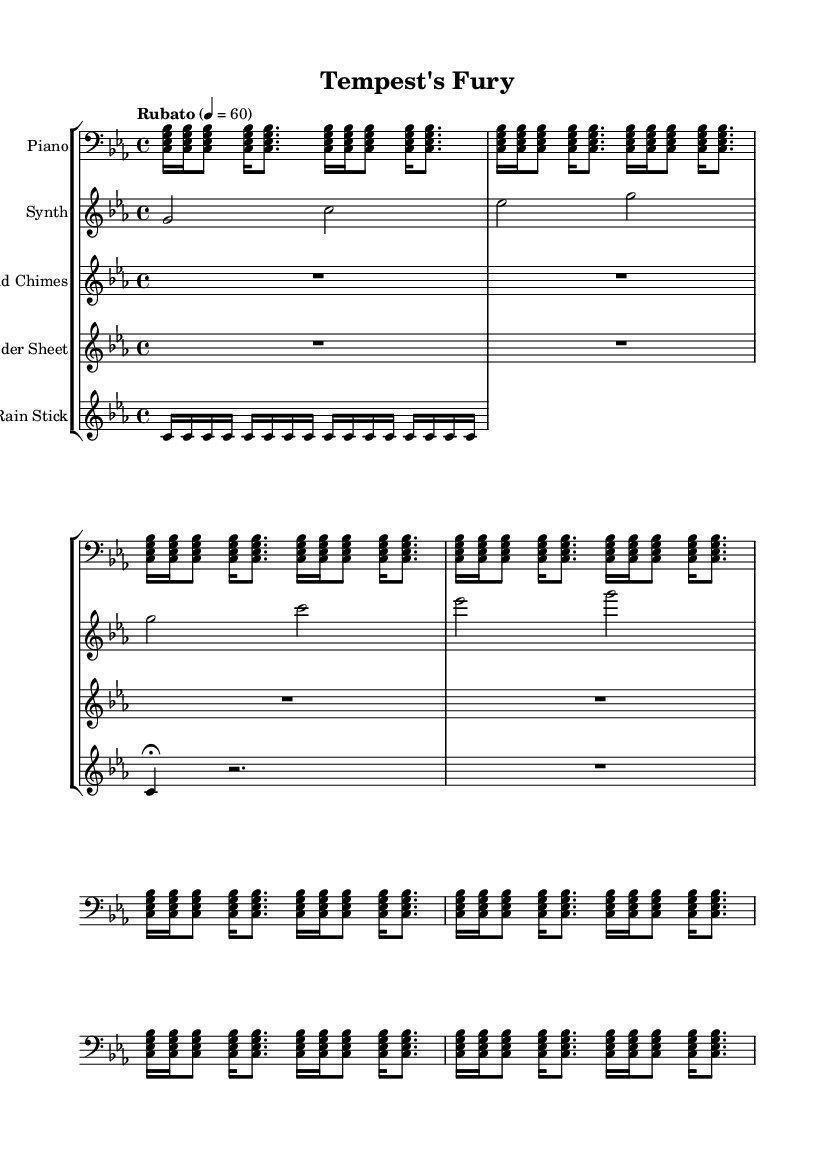What is the key signature of this music? The key signature is C minor, which has three flats.
Answer: C minor What is the time signature of the piece? The time signature is 4/4, indicating four beats per measure.
Answer: 4/4 What tempo is indicated for this composition? The tempo indication is "Rubato" with a speed of quarter note equals 60 beats per minute, allowing for a flexible pace.
Answer: Rubato 4 = 60 How many distinct instrumental parts are present in the score? There are five distinct instrumental parts: Piano, Synth, Wind Chimes, Thunder Sheet, and Rain Stick.
Answer: Five What repeating pattern is found in the piano section? The piano section features a repeated motif of four notes played in succession, utilizing the chord which constantly expands and contracts in a rhythmic fashion.
Answer: <c, es, g, bes> What type of sound does the "Wind Chimes" section represent? The "Wind Chimes" section represents silence, illustrated by the rest, which contributes to the atmospheric soundscape and enhances the idea of a tranquil moment amidst a storm.
Answer: Rest (silence) Which instrument contributes to the thunder-like effect? The Thunder Sheet is the instrument specifically designed to create a thunder-like effect, as indicated by its use of rests and the fermata mark, emphasizing impact.
Answer: Thunder Sheet 